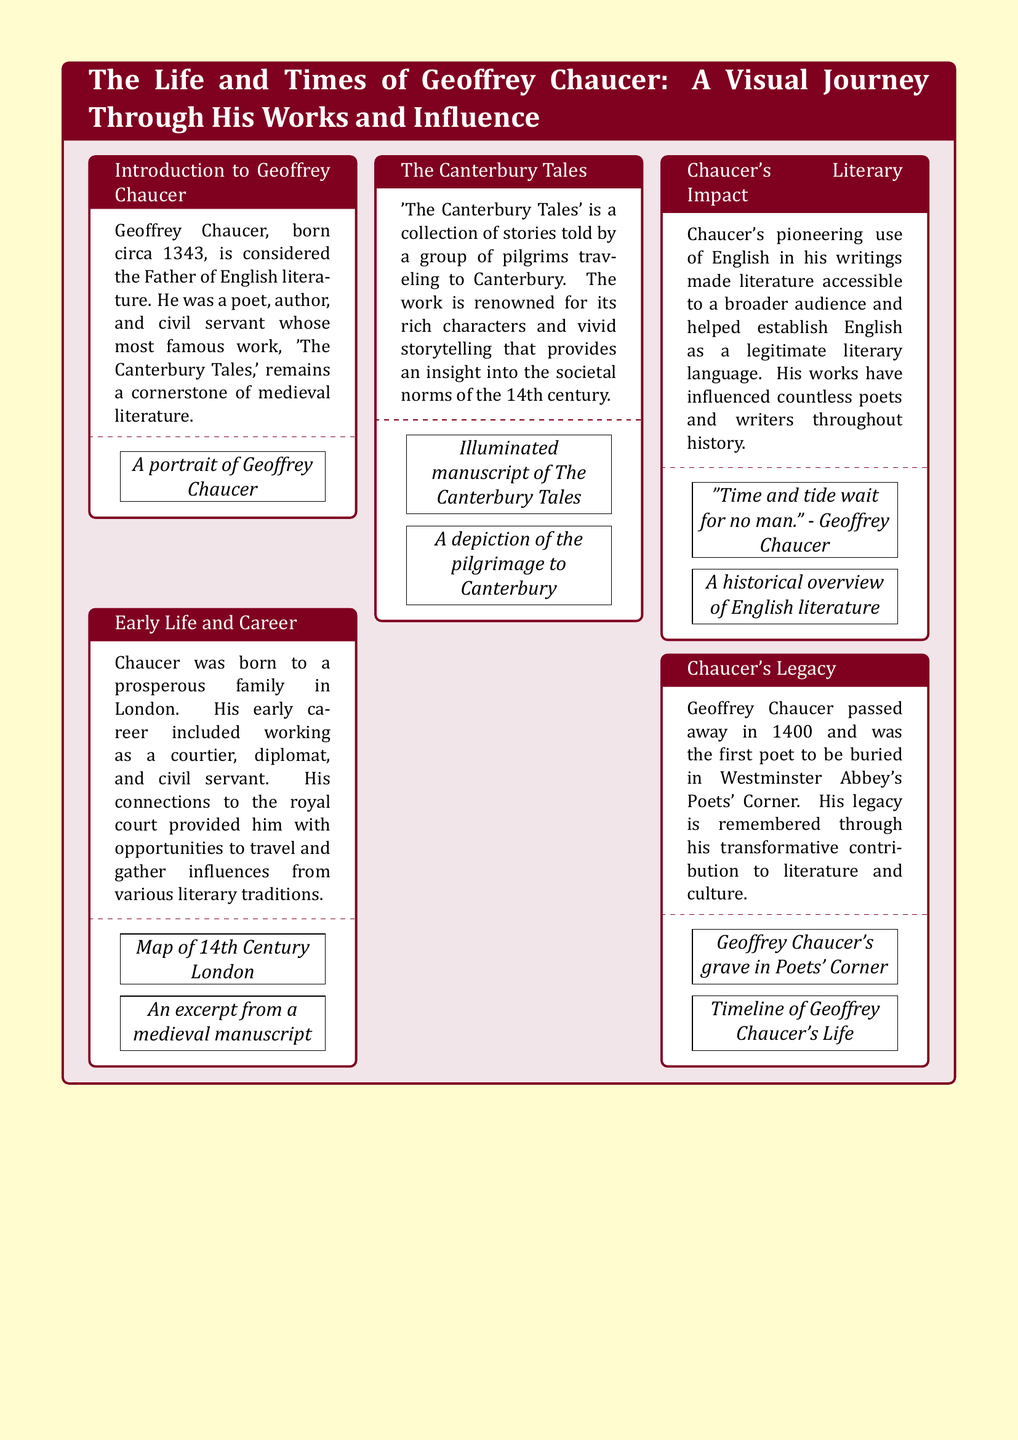What year was Geoffrey Chaucer born? The document states that Geoffrey Chaucer was born circa 1343.
Answer: circa 1343 What is Geoffrey Chaucer known as? The document refers to Geoffrey Chaucer as the Father of English literature.
Answer: Father of English literature What is the title of Chaucer's most famous work? The document mentions 'The Canterbury Tales' as Chaucer's most famous work.
Answer: The Canterbury Tales What significant change did Chaucer's writing bring to literature? The document notes that Chaucer’s use of English made literature accessible to a broader audience.
Answer: Accessible literature When did Geoffrey Chaucer pass away? The document specifies that Geoffrey Chaucer passed away in 1400.
Answer: 1400 Where is Chaucer buried? The document indicates that he was buried in Westminster Abbey's Poets' Corner.
Answer: Westminster Abbey's Poets' Corner What is a visual element presented in conjunction with the introduction? The document includes a portrait of Geoffrey Chaucer alongside his introduction.
Answer: A portrait of Geoffrey Chaucer Which work is described as providing insight into societal norms? The document describes 'The Canterbury Tales' as providing insight into the societal norms of the 14th century.
Answer: The Canterbury Tales What literary impact did Chaucer have according to the document? The document highlights that Chaucer helped establish English as a legitimate literary language.
Answer: Established English as a literary language 